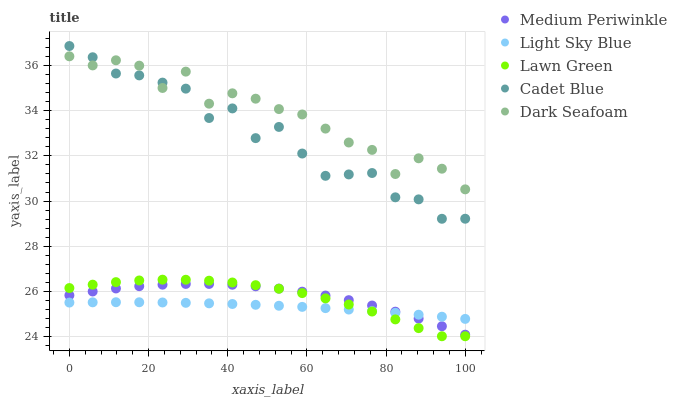Does Light Sky Blue have the minimum area under the curve?
Answer yes or no. Yes. Does Dark Seafoam have the maximum area under the curve?
Answer yes or no. Yes. Does Lawn Green have the minimum area under the curve?
Answer yes or no. No. Does Lawn Green have the maximum area under the curve?
Answer yes or no. No. Is Light Sky Blue the smoothest?
Answer yes or no. Yes. Is Cadet Blue the roughest?
Answer yes or no. Yes. Is Lawn Green the smoothest?
Answer yes or no. No. Is Lawn Green the roughest?
Answer yes or no. No. Does Lawn Green have the lowest value?
Answer yes or no. Yes. Does Dark Seafoam have the lowest value?
Answer yes or no. No. Does Cadet Blue have the highest value?
Answer yes or no. Yes. Does Lawn Green have the highest value?
Answer yes or no. No. Is Light Sky Blue less than Cadet Blue?
Answer yes or no. Yes. Is Cadet Blue greater than Medium Periwinkle?
Answer yes or no. Yes. Does Lawn Green intersect Medium Periwinkle?
Answer yes or no. Yes. Is Lawn Green less than Medium Periwinkle?
Answer yes or no. No. Is Lawn Green greater than Medium Periwinkle?
Answer yes or no. No. Does Light Sky Blue intersect Cadet Blue?
Answer yes or no. No. 